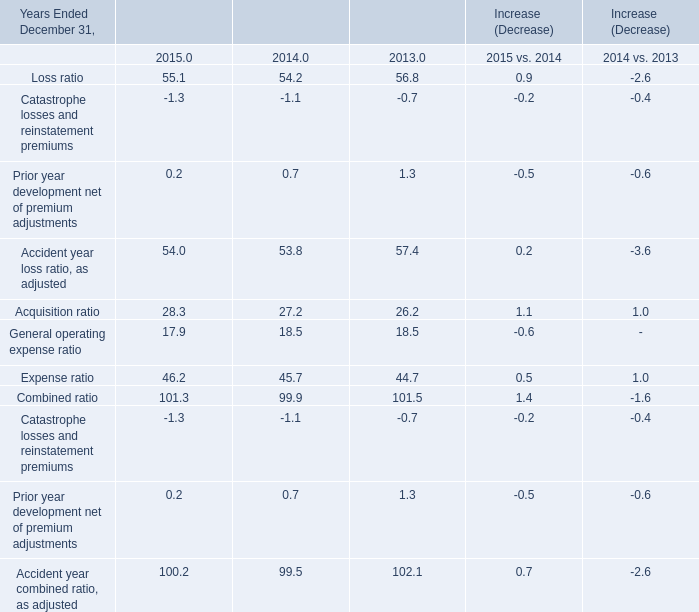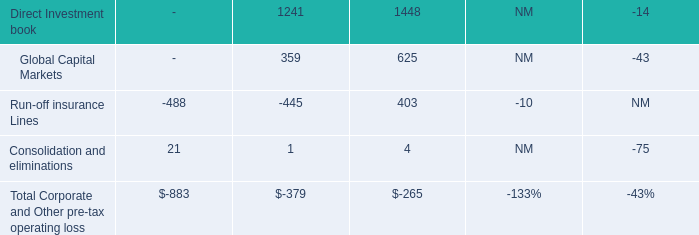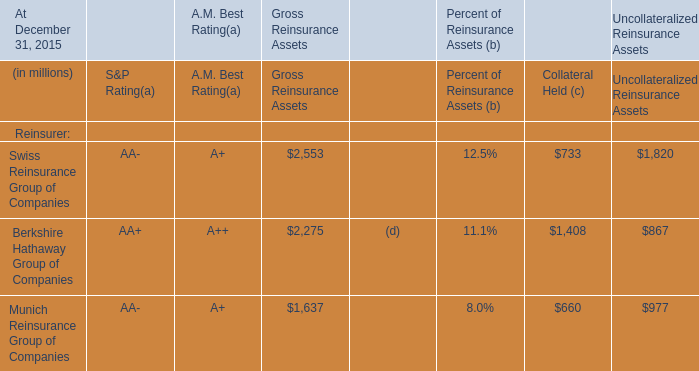What's the average of Loss ratio and Acquisition ratio and Expense ratio in 2015? (in %) 
Computations: (((55.1 + 28.3) + 46.2) / 3)
Answer: 43.2. 